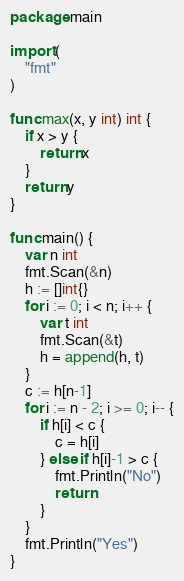<code> <loc_0><loc_0><loc_500><loc_500><_Go_>package main

import (
	"fmt"
)

func max(x, y int) int {
	if x > y {
		return x
	}
	return y
}

func main() {
	var n int
	fmt.Scan(&n)
	h := []int{}
	for i := 0; i < n; i++ {
		var t int
		fmt.Scan(&t)
		h = append(h, t)
	}
	c := h[n-1]
	for i := n - 2; i >= 0; i-- {
		if h[i] < c {
			c = h[i]
		} else if h[i]-1 > c {
			fmt.Println("No")
			return
		}
	}
	fmt.Println("Yes")
}
</code> 